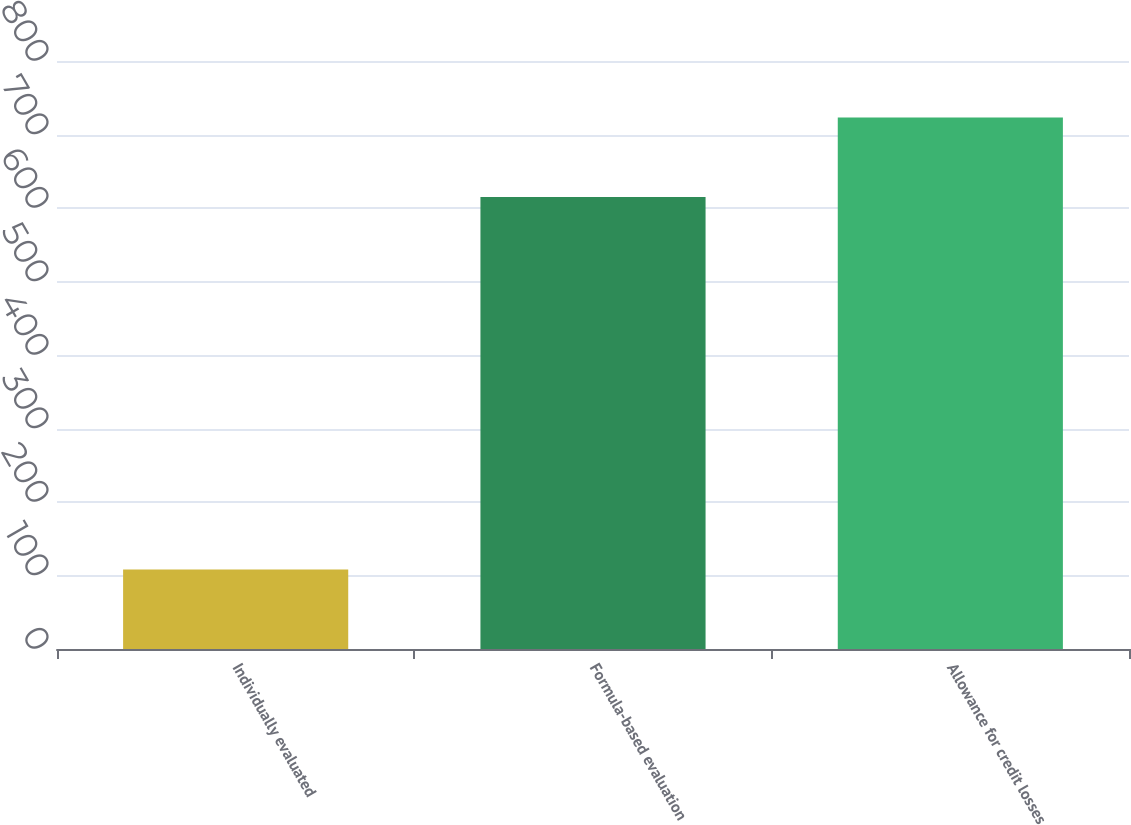Convert chart. <chart><loc_0><loc_0><loc_500><loc_500><bar_chart><fcel>Individually evaluated<fcel>Formula-based evaluation<fcel>Allowance for credit losses<nl><fcel>108<fcel>615<fcel>723<nl></chart> 